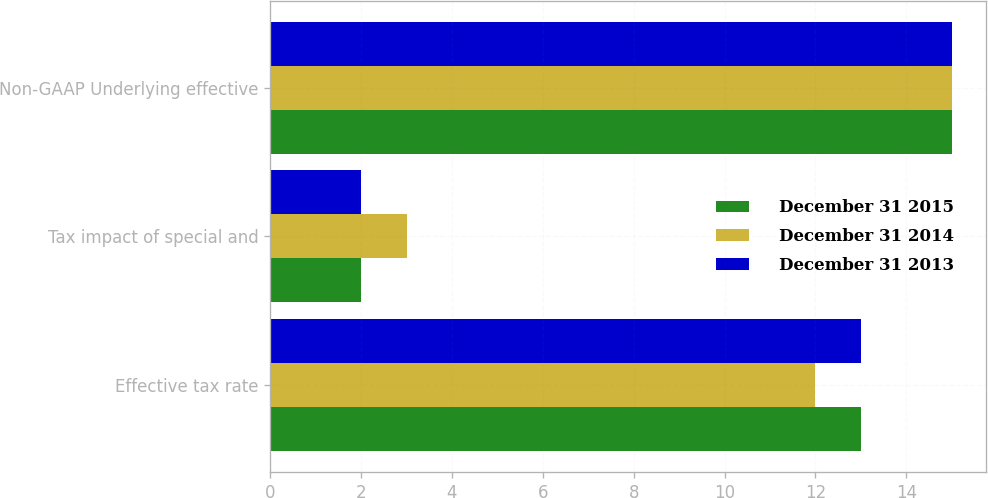<chart> <loc_0><loc_0><loc_500><loc_500><stacked_bar_chart><ecel><fcel>Effective tax rate<fcel>Tax impact of special and<fcel>Non-GAAP Underlying effective<nl><fcel>December 31 2015<fcel>13<fcel>2<fcel>15<nl><fcel>December 31 2014<fcel>12<fcel>3<fcel>15<nl><fcel>December 31 2013<fcel>13<fcel>2<fcel>15<nl></chart> 